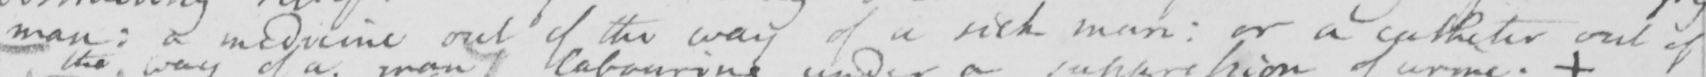Can you tell me what this handwritten text says? man :  a medicine out of the way of a sick man :  or a catheter out of 